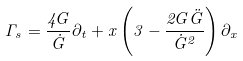Convert formula to latex. <formula><loc_0><loc_0><loc_500><loc_500>\Gamma _ { s } = \frac { 4 G } { \dot { G } } \partial _ { t } + x \left ( 3 - \frac { 2 G \ddot { G } } { \dot { G } ^ { 2 } } \right ) \partial _ { x }</formula> 